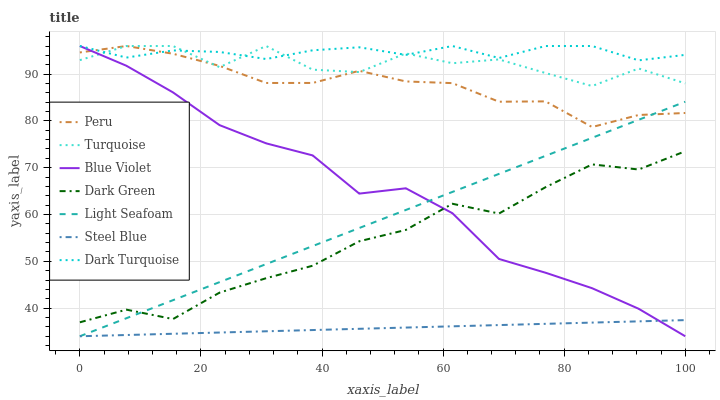Does Dark Turquoise have the minimum area under the curve?
Answer yes or no. No. Does Steel Blue have the maximum area under the curve?
Answer yes or no. No. Is Dark Turquoise the smoothest?
Answer yes or no. No. Is Dark Turquoise the roughest?
Answer yes or no. No. Does Dark Turquoise have the lowest value?
Answer yes or no. No. Does Steel Blue have the highest value?
Answer yes or no. No. Is Dark Green less than Dark Turquoise?
Answer yes or no. Yes. Is Peru greater than Steel Blue?
Answer yes or no. Yes. Does Dark Green intersect Dark Turquoise?
Answer yes or no. No. 